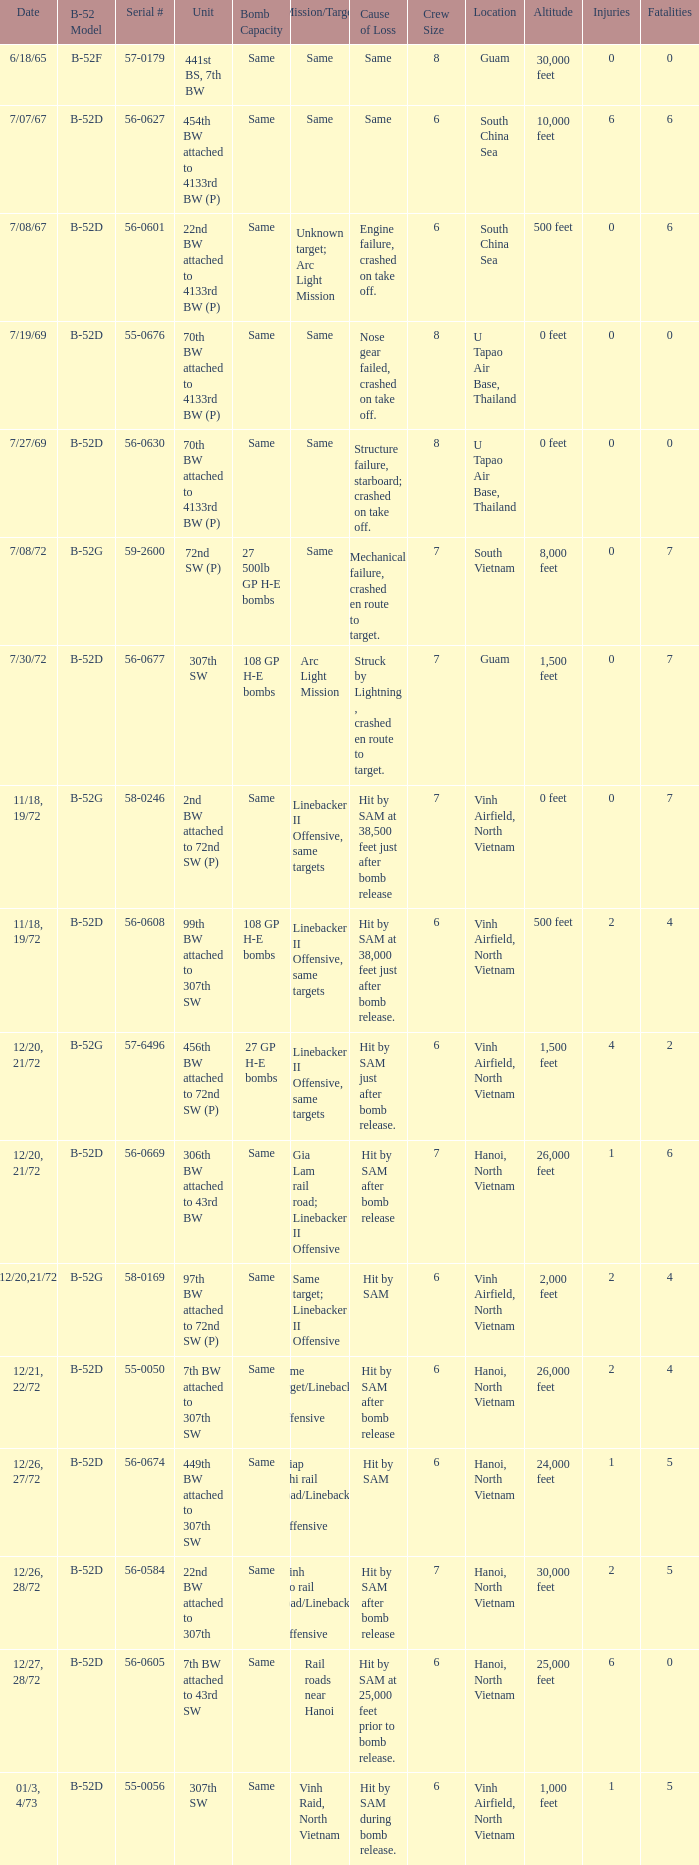When hit by sam at 38,500 feet just after bomb release was the cause of loss what is the mission/target? Linebacker II Offensive, same targets. 